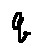<formula> <loc_0><loc_0><loc_500><loc_500>q</formula> 